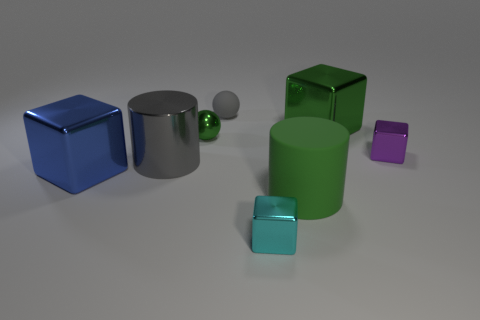Is the material of the big blue object the same as the small block behind the large green cylinder?
Offer a terse response. Yes. Does the matte cylinder have the same color as the large metallic object right of the cyan block?
Your answer should be compact. Yes. How many other things are there of the same color as the metal sphere?
Provide a succinct answer. 2. Are there more metallic objects that are on the left side of the large metal cylinder than blue metallic objects behind the big blue metallic cube?
Your answer should be compact. Yes. Are there any large green matte cylinders right of the large blue cube?
Offer a terse response. Yes. What is the object that is both behind the small green metallic thing and on the right side of the green matte cylinder made of?
Ensure brevity in your answer.  Metal. The other large object that is the same shape as the blue metallic thing is what color?
Your answer should be compact. Green. Is there a tiny gray object to the left of the small object in front of the big rubber thing?
Keep it short and to the point. Yes. The cyan block has what size?
Offer a very short reply. Small. There is a small thing that is both behind the purple cube and in front of the small gray sphere; what shape is it?
Your response must be concise. Sphere. 